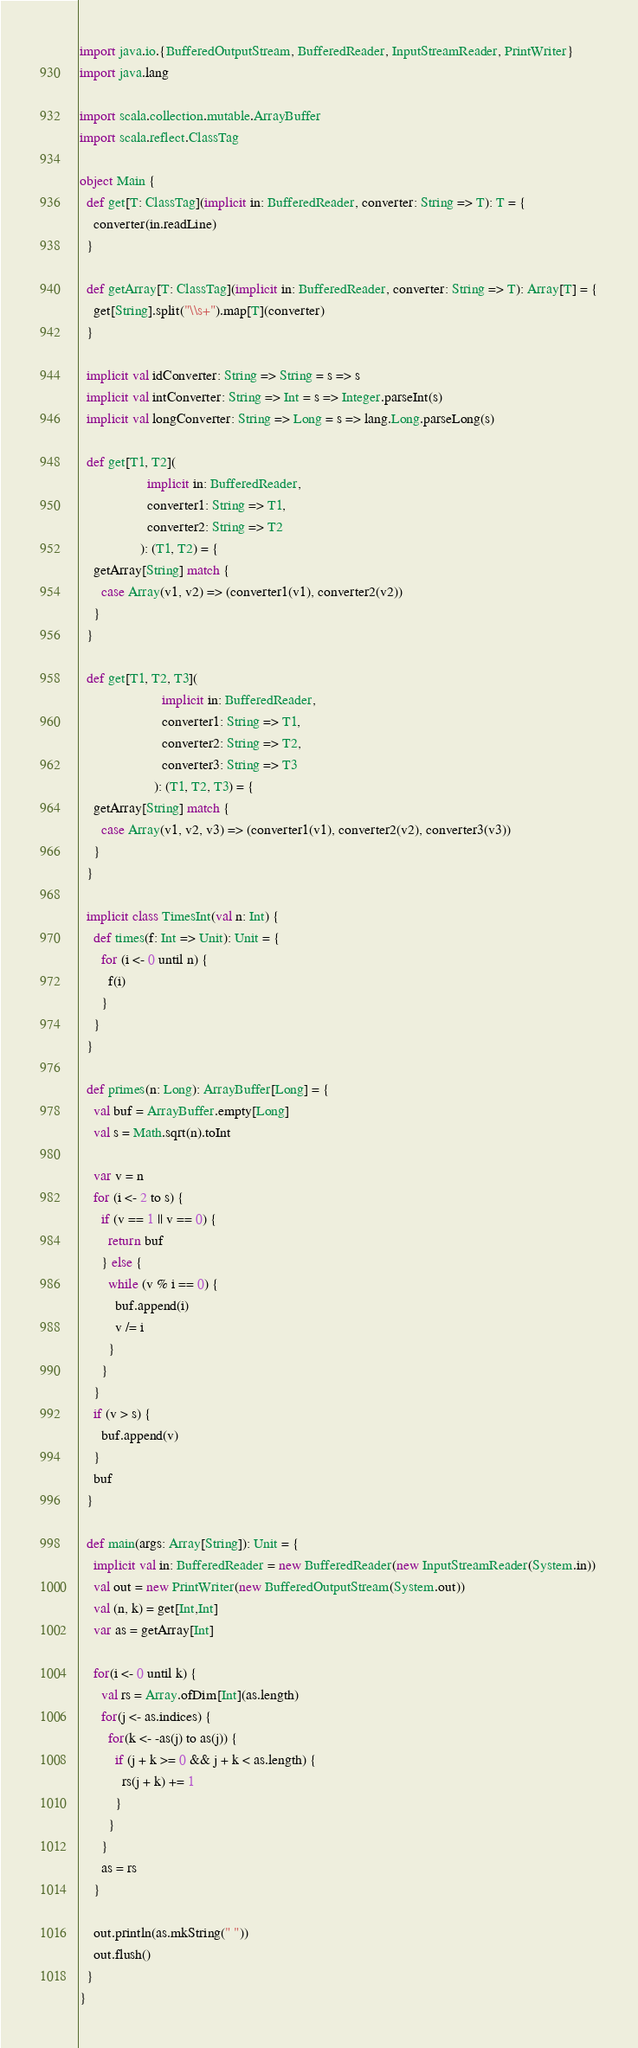Convert code to text. <code><loc_0><loc_0><loc_500><loc_500><_Scala_>import java.io.{BufferedOutputStream, BufferedReader, InputStreamReader, PrintWriter}
import java.lang

import scala.collection.mutable.ArrayBuffer
import scala.reflect.ClassTag

object Main {
  def get[T: ClassTag](implicit in: BufferedReader, converter: String => T): T = {
    converter(in.readLine)
  }

  def getArray[T: ClassTag](implicit in: BufferedReader, converter: String => T): Array[T] = {
    get[String].split("\\s+").map[T](converter)
  }

  implicit val idConverter: String => String = s => s
  implicit val intConverter: String => Int = s => Integer.parseInt(s)
  implicit val longConverter: String => Long = s => lang.Long.parseLong(s)

  def get[T1, T2](
                   implicit in: BufferedReader,
                   converter1: String => T1,
                   converter2: String => T2
                 ): (T1, T2) = {
    getArray[String] match {
      case Array(v1, v2) => (converter1(v1), converter2(v2))
    }
  }

  def get[T1, T2, T3](
                       implicit in: BufferedReader,
                       converter1: String => T1,
                       converter2: String => T2,
                       converter3: String => T3
                     ): (T1, T2, T3) = {
    getArray[String] match {
      case Array(v1, v2, v3) => (converter1(v1), converter2(v2), converter3(v3))
    }
  }

  implicit class TimesInt(val n: Int) {
    def times(f: Int => Unit): Unit = {
      for (i <- 0 until n) {
        f(i)
      }
    }
  }

  def primes(n: Long): ArrayBuffer[Long] = {
    val buf = ArrayBuffer.empty[Long]
    val s = Math.sqrt(n).toInt

    var v = n
    for (i <- 2 to s) {
      if (v == 1 || v == 0) {
        return buf
      } else {
        while (v % i == 0) {
          buf.append(i)
          v /= i
        }
      }
    }
    if (v > s) {
      buf.append(v)
    }
    buf
  }

  def main(args: Array[String]): Unit = {
    implicit val in: BufferedReader = new BufferedReader(new InputStreamReader(System.in))
    val out = new PrintWriter(new BufferedOutputStream(System.out))
    val (n, k) = get[Int,Int]
    var as = getArray[Int]

    for(i <- 0 until k) {
      val rs = Array.ofDim[Int](as.length)
      for(j <- as.indices) {
        for(k <- -as(j) to as(j)) {
          if (j + k >= 0 && j + k < as.length) {
            rs(j + k) += 1
          }
        }
      }
      as = rs
    }

    out.println(as.mkString(" "))
    out.flush()
  }
}</code> 